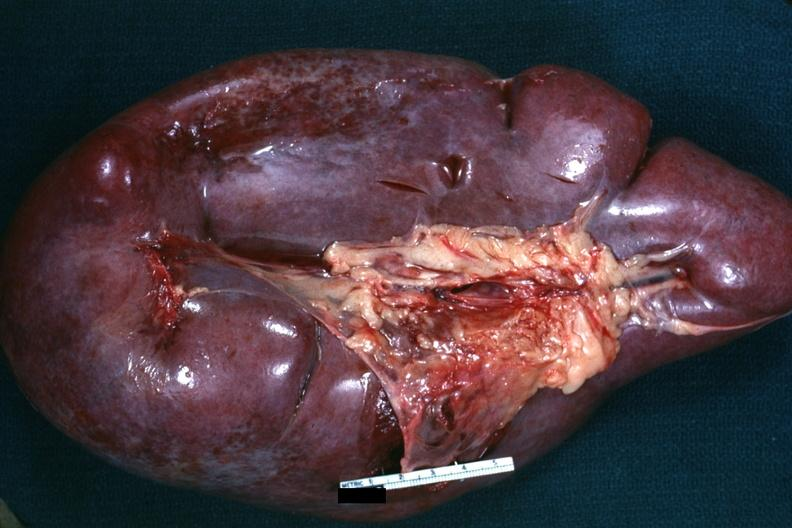s acute myelogenous leukemia present?
Answer the question using a single word or phrase. Yes 